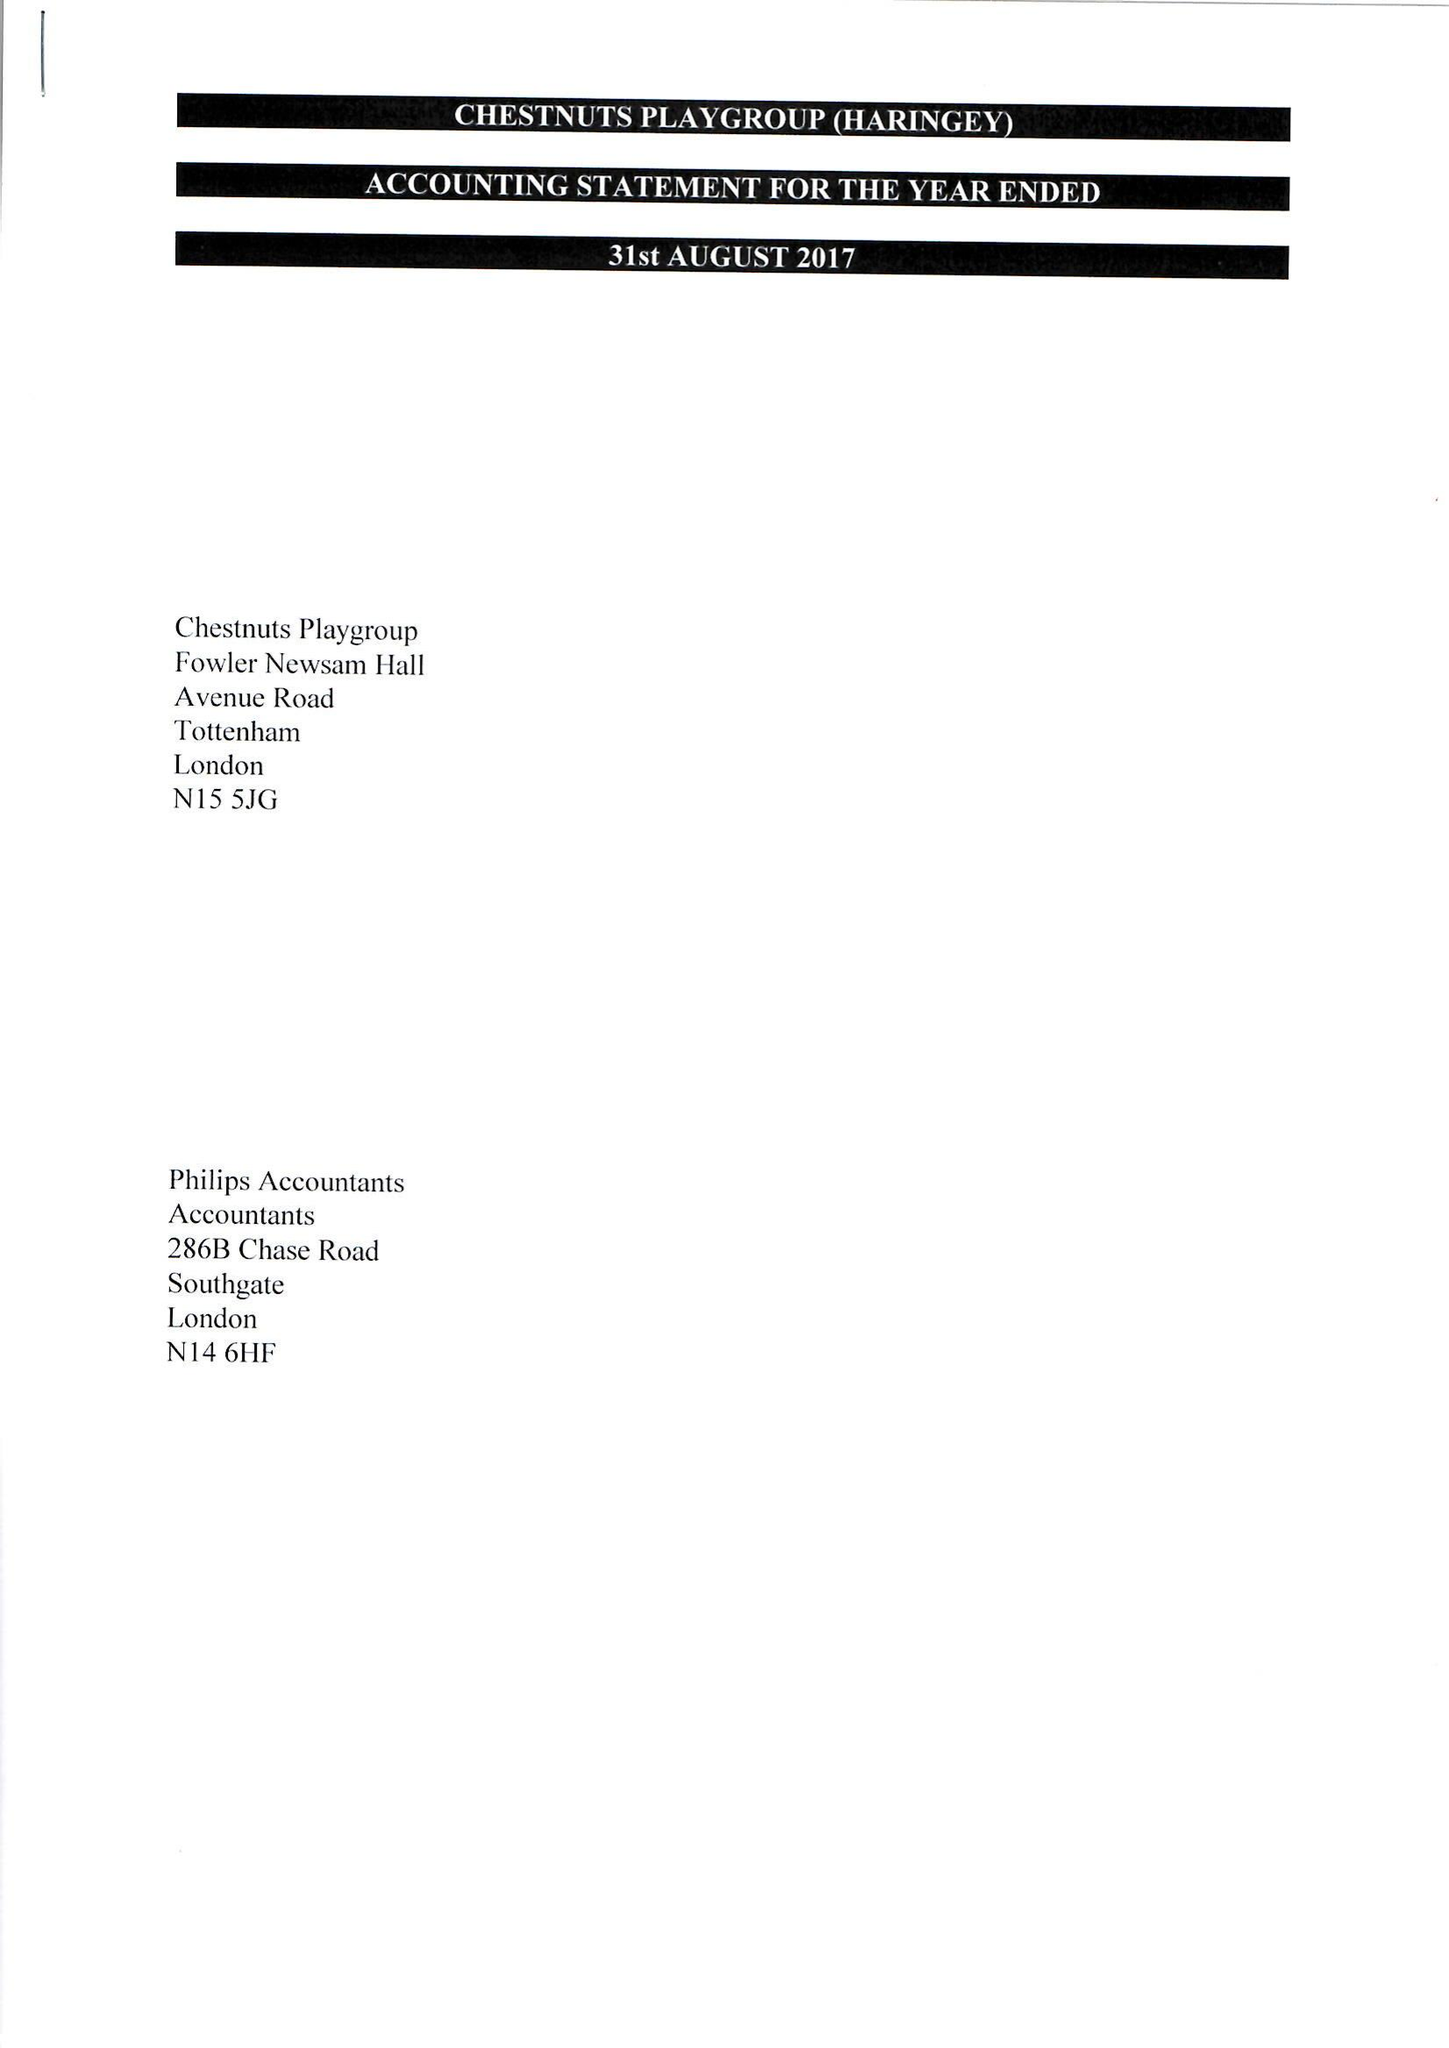What is the value for the report_date?
Answer the question using a single word or phrase. 2015-08-31 